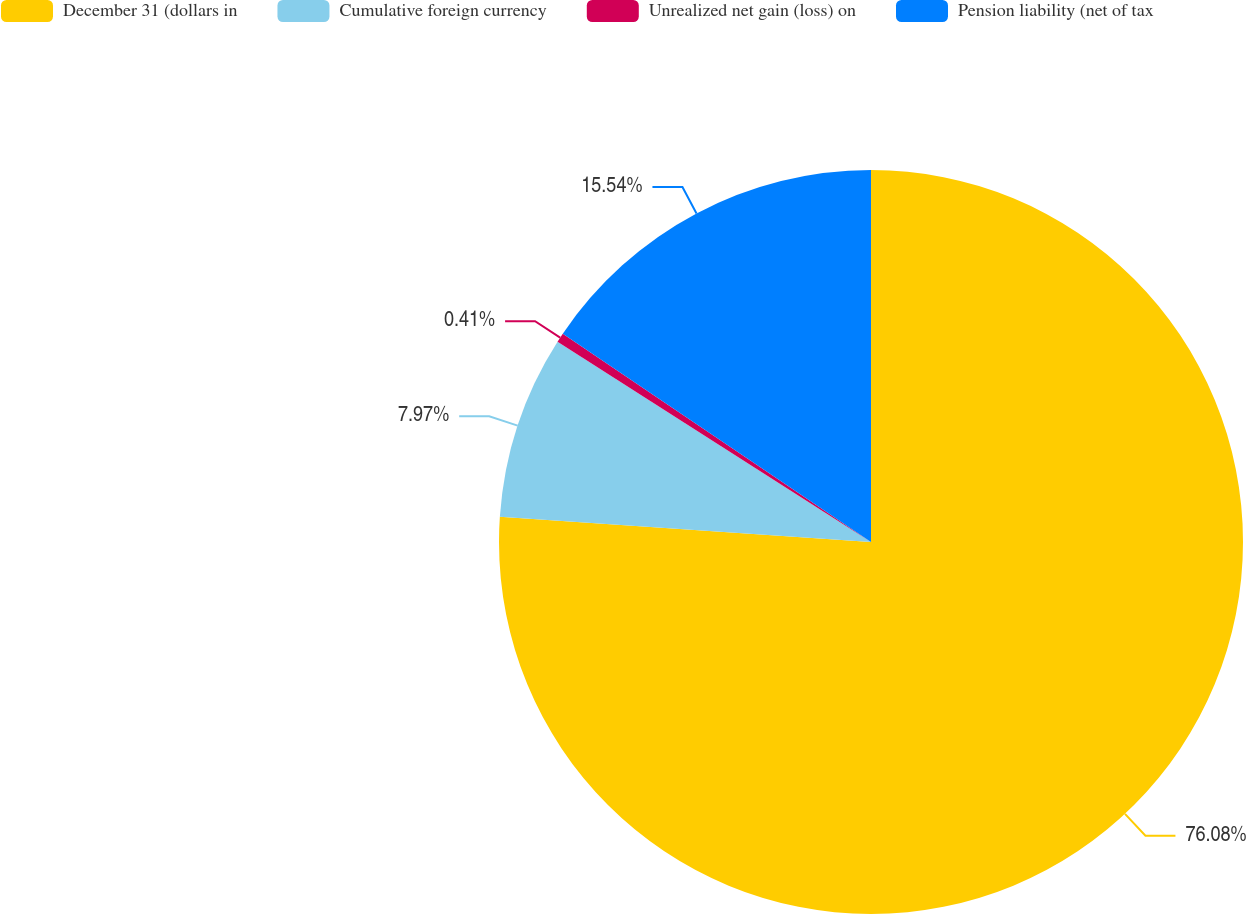Convert chart to OTSL. <chart><loc_0><loc_0><loc_500><loc_500><pie_chart><fcel>December 31 (dollars in<fcel>Cumulative foreign currency<fcel>Unrealized net gain (loss) on<fcel>Pension liability (net of tax<nl><fcel>76.08%<fcel>7.97%<fcel>0.41%<fcel>15.54%<nl></chart> 